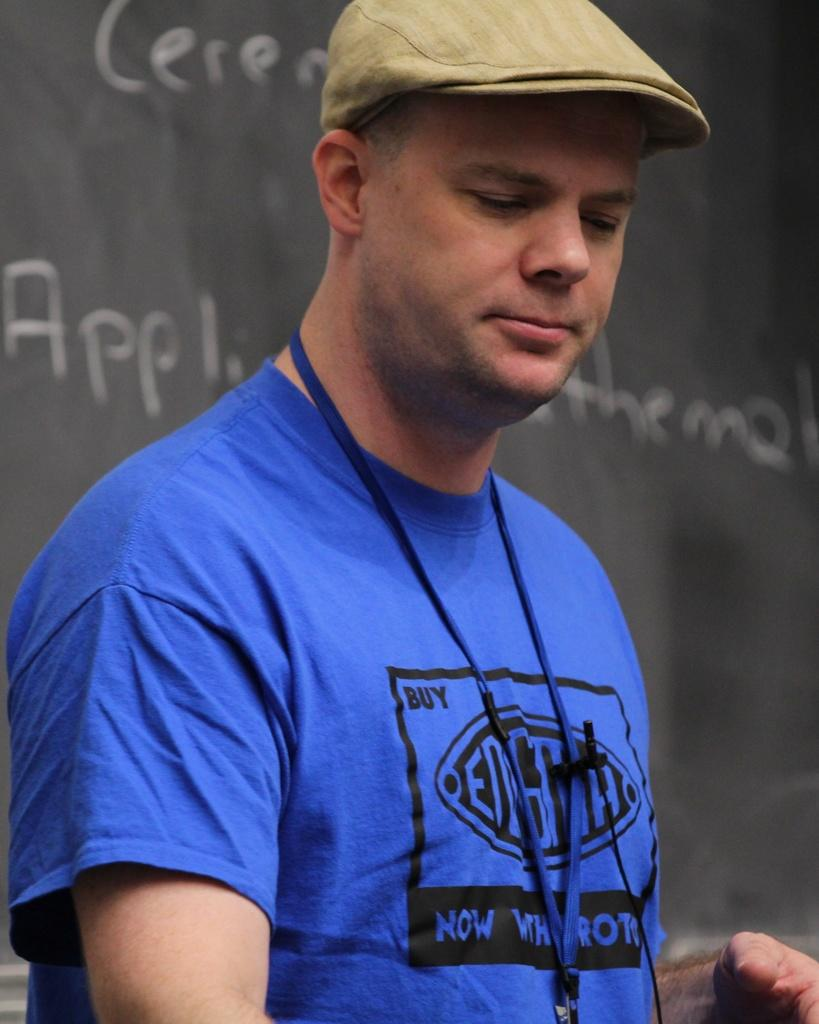<image>
Give a short and clear explanation of the subsequent image. a man with the word now in his blue shirt 